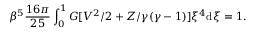Convert formula to latex. <formula><loc_0><loc_0><loc_500><loc_500>\beta ^ { 5 } { \frac { 1 6 \pi } { 2 5 } } \int _ { 0 } ^ { 1 } G [ V ^ { 2 } / 2 + Z / \gamma ( \gamma - 1 ) ] \xi ^ { 4 } d \xi = 1 .</formula> 